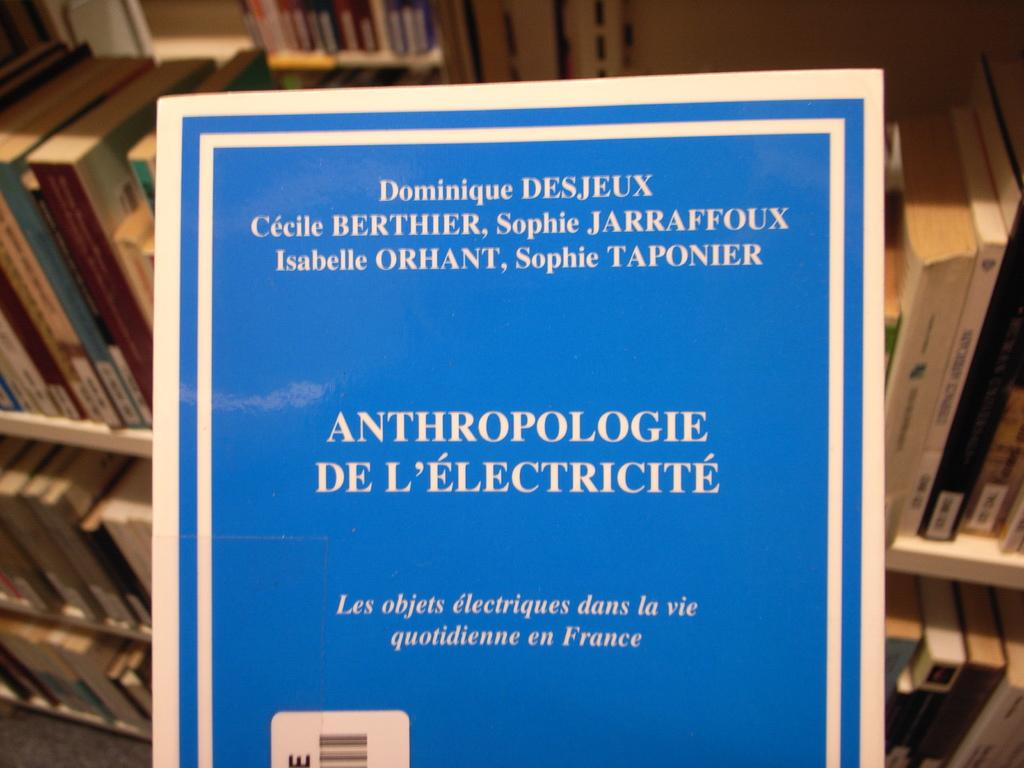Provide a one-sentence caption for the provided image. A document regarding anthropologie de l'electricite by Dominique Desjeeux. 